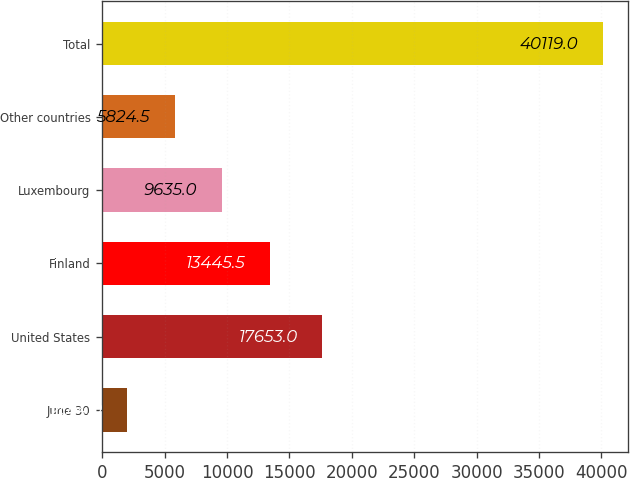Convert chart to OTSL. <chart><loc_0><loc_0><loc_500><loc_500><bar_chart><fcel>June 30<fcel>United States<fcel>Finland<fcel>Luxembourg<fcel>Other countries<fcel>Total<nl><fcel>2014<fcel>17653<fcel>13445.5<fcel>9635<fcel>5824.5<fcel>40119<nl></chart> 